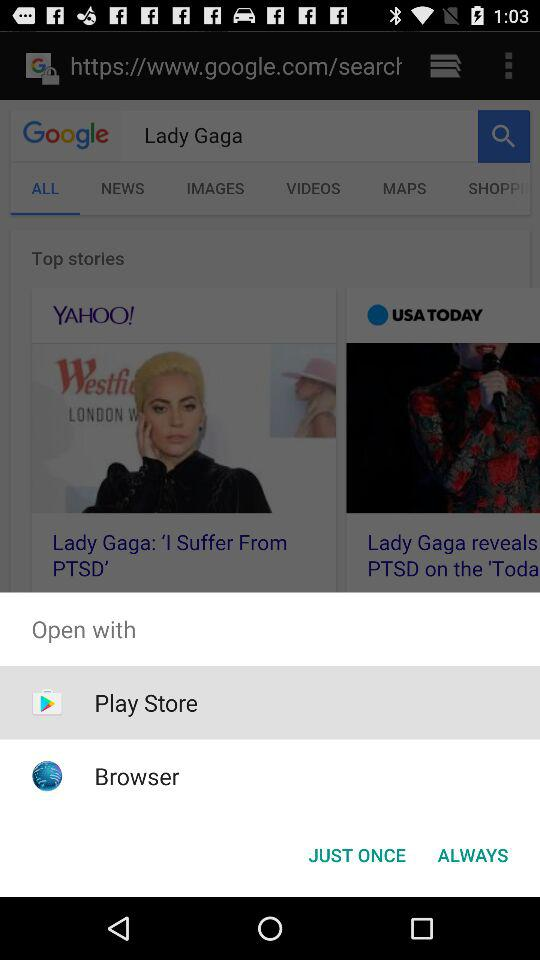What is the name of the singer? The name of the singer is Lady Gaga. 